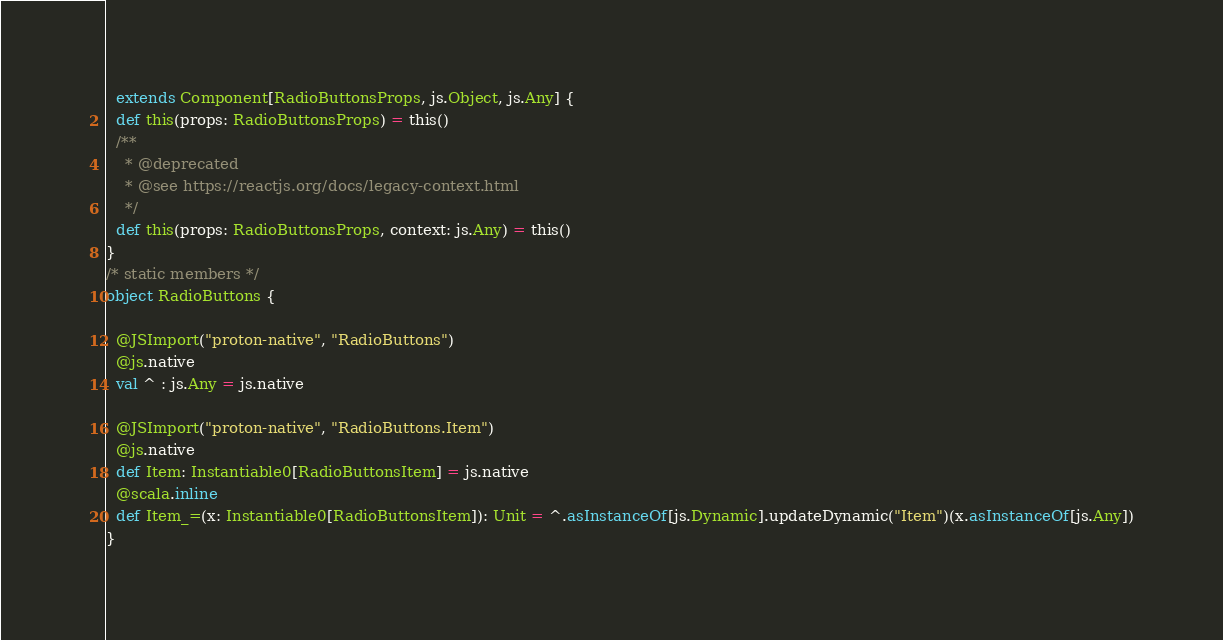<code> <loc_0><loc_0><loc_500><loc_500><_Scala_>  extends Component[RadioButtonsProps, js.Object, js.Any] {
  def this(props: RadioButtonsProps) = this()
  /**
    * @deprecated
    * @see https://reactjs.org/docs/legacy-context.html
    */
  def this(props: RadioButtonsProps, context: js.Any) = this()
}
/* static members */
object RadioButtons {
  
  @JSImport("proton-native", "RadioButtons")
  @js.native
  val ^ : js.Any = js.native
  
  @JSImport("proton-native", "RadioButtons.Item")
  @js.native
  def Item: Instantiable0[RadioButtonsItem] = js.native
  @scala.inline
  def Item_=(x: Instantiable0[RadioButtonsItem]): Unit = ^.asInstanceOf[js.Dynamic].updateDynamic("Item")(x.asInstanceOf[js.Any])
}
</code> 